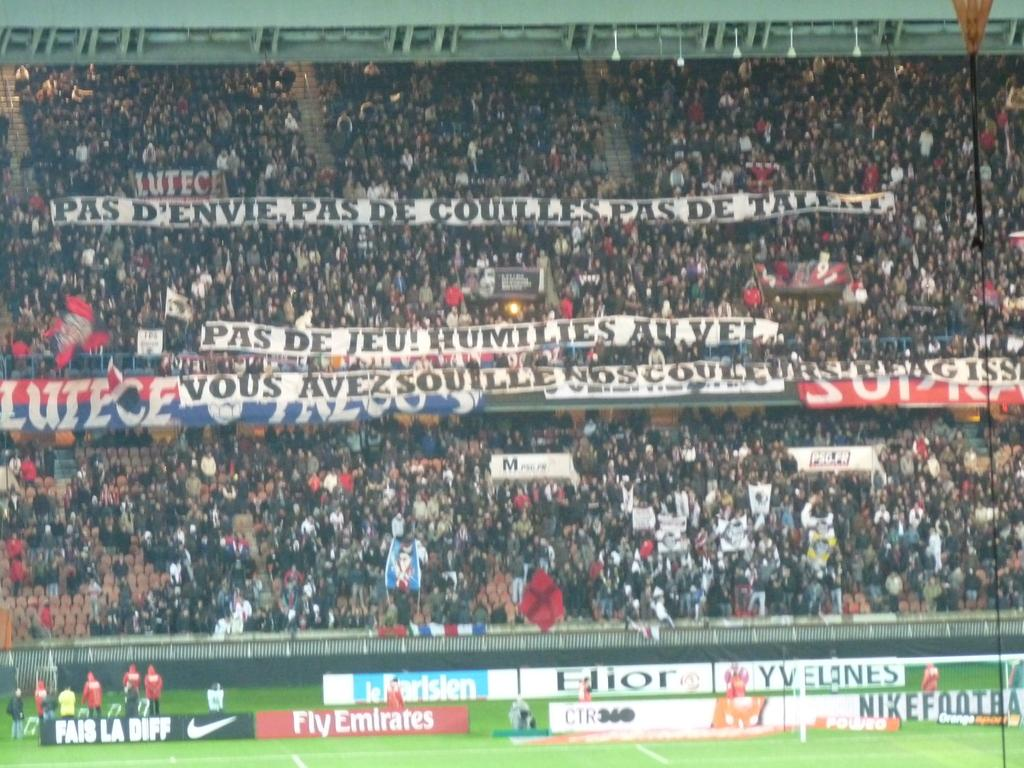<image>
Present a compact description of the photo's key features. a sports game with adverts on the side, one of which is for fly emirates. 